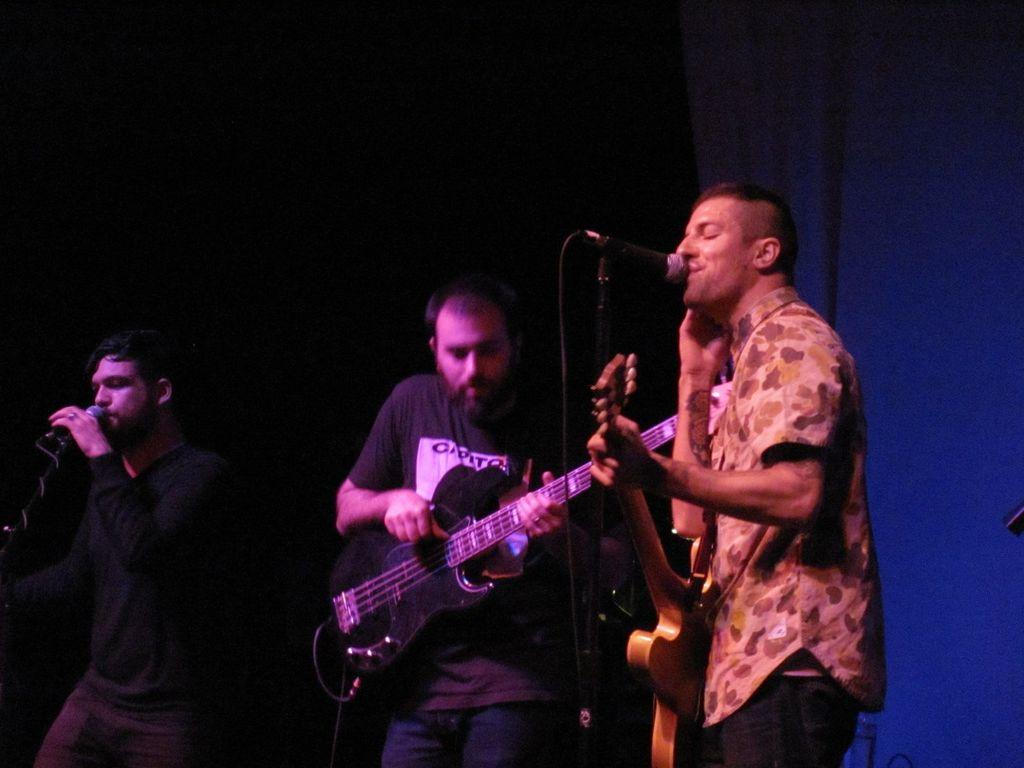What is the overall color scheme of the image? The background of the image is dark. How many people are in the image? There are two men in the image. What are the men doing in the image? The men are standing in front of a microphone. What instrument is one of the men playing? One of the men is playing a guitar. What might the other man be doing, based on the transcript? The other man is likely singing, as mentioned in the transcript. What type of quiver can be seen hanging on the wall in the image? There is no quiver present in the image. Can you hear the bell ringing in the background of the image? The image is a still photograph, so there is no sound or bell ringing. 